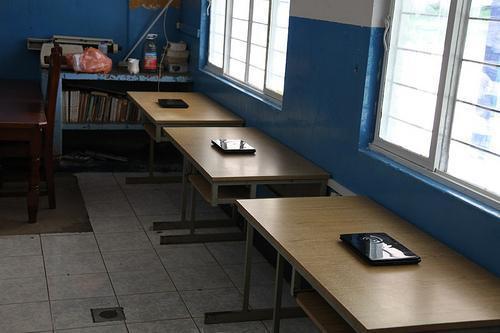How many desks are in a row?
Give a very brief answer. 3. How many tables do not have something on top of them?
Give a very brief answer. 1. 